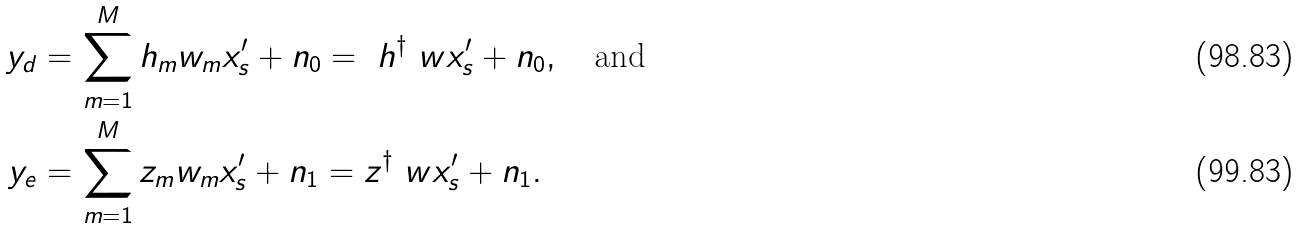Convert formula to latex. <formula><loc_0><loc_0><loc_500><loc_500>y _ { d } & = \sum _ { m = 1 } ^ { M } h _ { m } w _ { m } x _ { s } ^ { \prime } + n _ { 0 } = \ h ^ { \dagger } \ w x _ { s } ^ { \prime } + n _ { 0 } , \quad \text {and} \\ y _ { e } & = \sum _ { m = 1 } ^ { M } z _ { m } w _ { m } x _ { s } ^ { \prime } + n _ { 1 } = z ^ { \dagger } \ w x _ { s } ^ { \prime } + n _ { 1 } .</formula> 